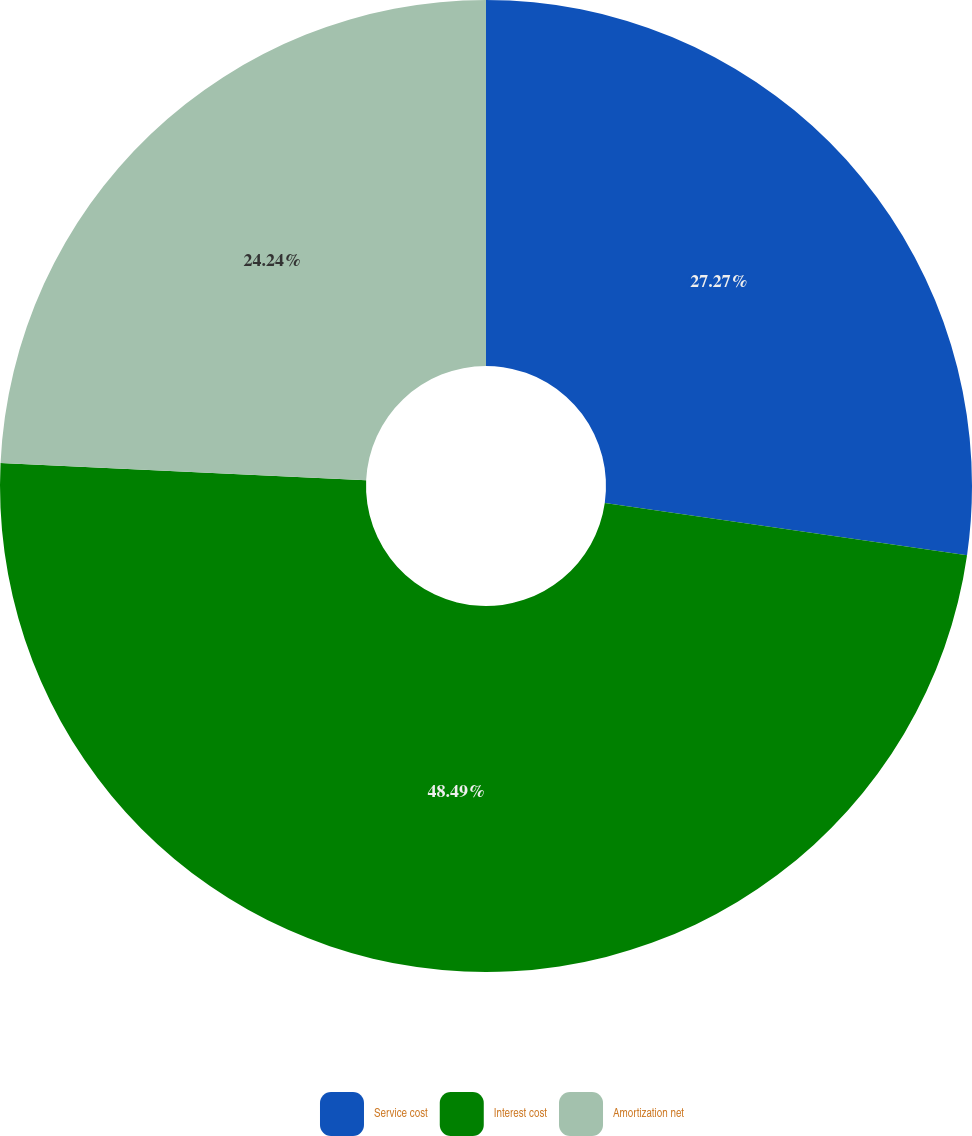Convert chart to OTSL. <chart><loc_0><loc_0><loc_500><loc_500><pie_chart><fcel>Service cost<fcel>Interest cost<fcel>Amortization net<nl><fcel>27.27%<fcel>48.48%<fcel>24.24%<nl></chart> 